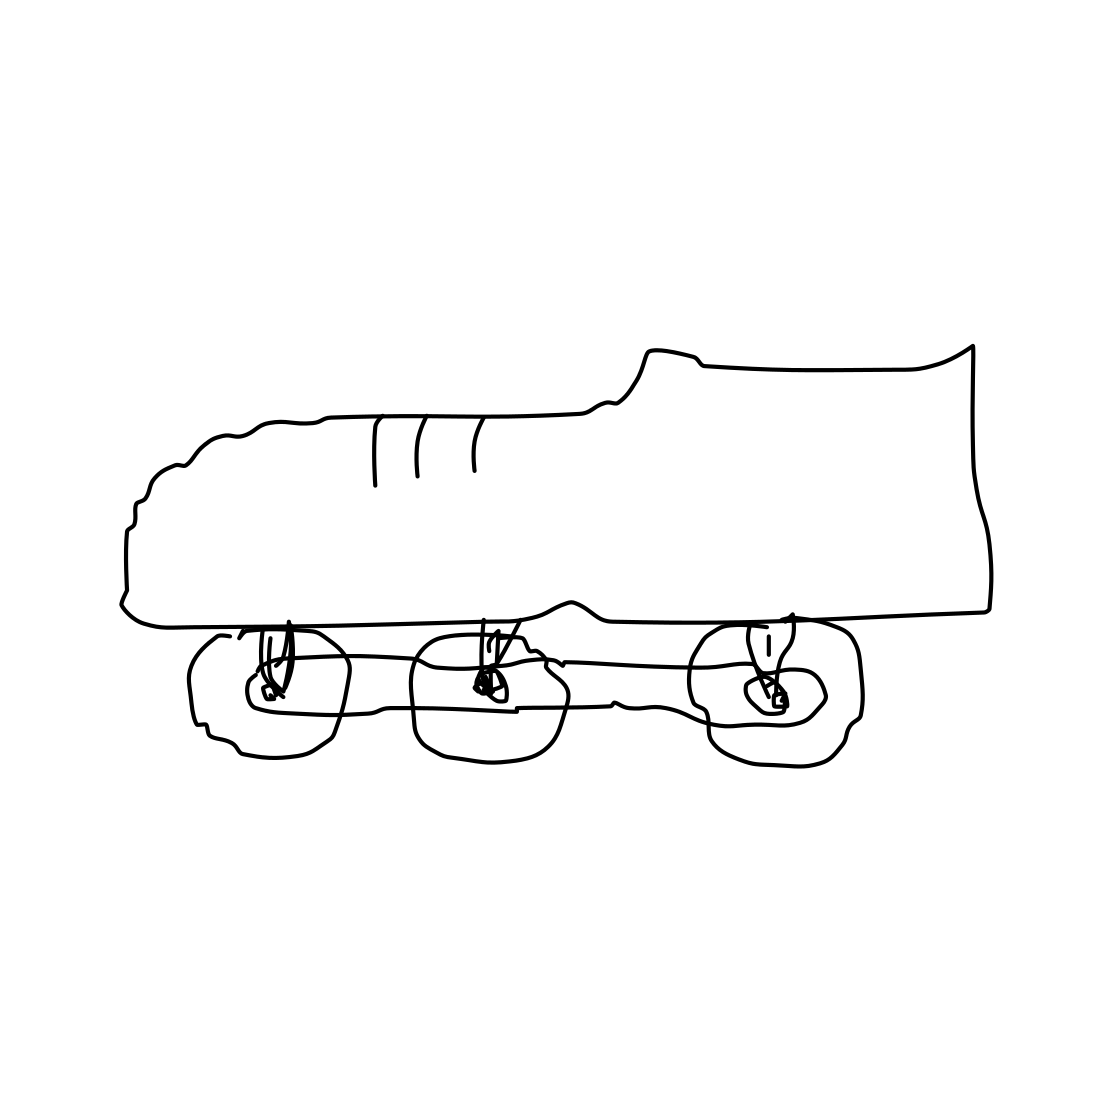Can you tell me more about this unusual design of a sneaker with rollerskates? Certainly! The image shows a conceptual design combining a sneaker with rollerskates. This hybrid design suggests a focus on mobility and sportiness, possibly intended for quick transitions between walking and skating. Who might find this design useful? Such a design would be particularly appealing to young adults and teenagers who enjoy inline skating or are looking for a convenient, versatile mode of transport. It's great for urban environments where quick mobility adjustments are often needed. 